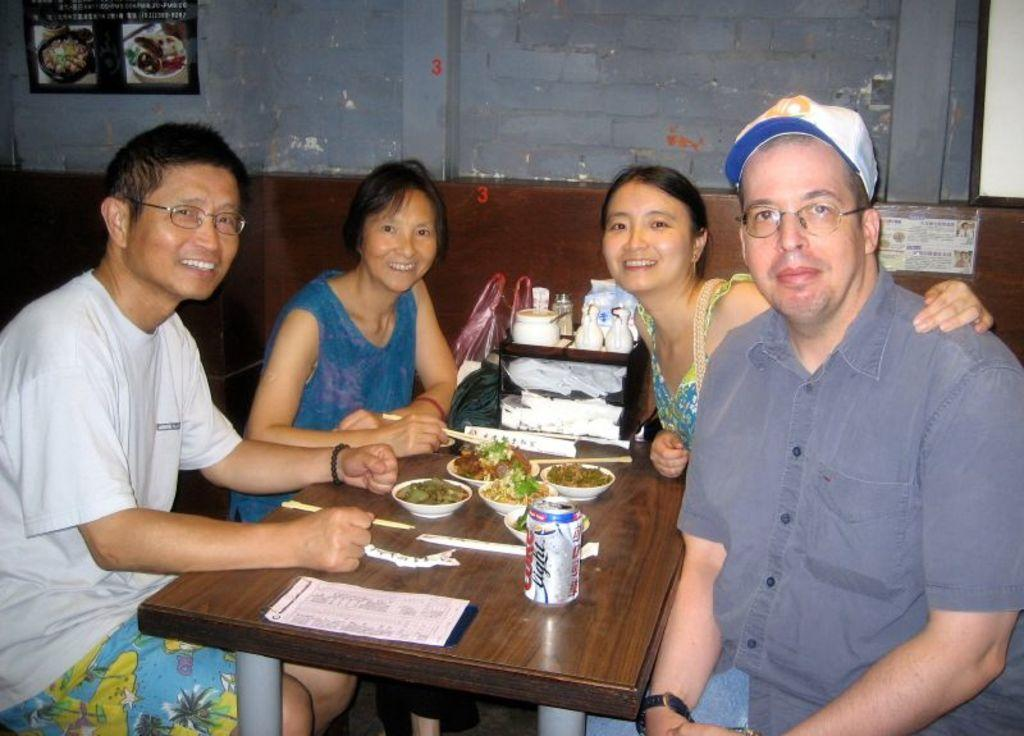How many people are in the image? There are four people in the image. Can you describe the gender of the people in the image? Two of the people are women, and two are men. What is the main object in the image? There is a table in the image. What can be found on the table? Food and a tin are present on the table. What are the people in the image writing on the tin? There is no writing activity taking place in the image, and the tin is not being used for writing. 